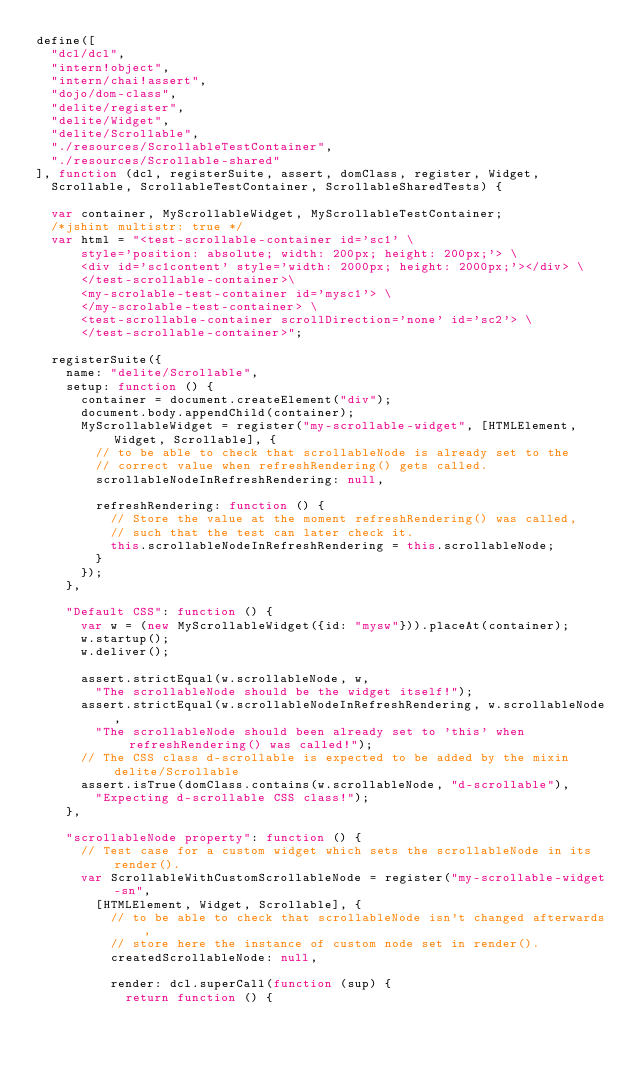Convert code to text. <code><loc_0><loc_0><loc_500><loc_500><_JavaScript_>define([
	"dcl/dcl",
	"intern!object",
	"intern/chai!assert",
	"dojo/dom-class",
	"delite/register",
	"delite/Widget",
	"delite/Scrollable",
	"./resources/ScrollableTestContainer",
	"./resources/Scrollable-shared"
], function (dcl, registerSuite, assert, domClass, register, Widget,
	Scrollable, ScrollableTestContainer, ScrollableSharedTests) {

	var container, MyScrollableWidget, MyScrollableTestContainer;
	/*jshint multistr: true */
	var html = "<test-scrollable-container id='sc1' \
			style='position: absolute; width: 200px; height: 200px;'> \
			<div id='sc1content' style='width: 2000px; height: 2000px;'></div> \
			</test-scrollable-container>\
			<my-scrolable-test-container id='mysc1'> \
			</my-scrolable-test-container> \
			<test-scrollable-container scrollDirection='none' id='sc2'> \
			</test-scrollable-container>";

	registerSuite({
		name: "delite/Scrollable",
		setup: function () {
			container = document.createElement("div");
			document.body.appendChild(container);
			MyScrollableWidget = register("my-scrollable-widget", [HTMLElement, Widget, Scrollable], {
				// to be able to check that scrollableNode is already set to the 
				// correct value when refreshRendering() gets called.
				scrollableNodeInRefreshRendering: null,

				refreshRendering: function () {
					// Store the value at the moment refreshRendering() was called,
					// such that the test can later check it.
					this.scrollableNodeInRefreshRendering = this.scrollableNode;
				}
			});
		},

		"Default CSS": function () {
			var w = (new MyScrollableWidget({id: "mysw"})).placeAt(container);
			w.startup();
			w.deliver();

			assert.strictEqual(w.scrollableNode, w,
				"The scrollableNode should be the widget itself!");
			assert.strictEqual(w.scrollableNodeInRefreshRendering, w.scrollableNode,
				"The scrollableNode should been already set to 'this' when refreshRendering() was called!");
			// The CSS class d-scrollable is expected to be added by the mixin delite/Scrollable
			assert.isTrue(domClass.contains(w.scrollableNode, "d-scrollable"),
				"Expecting d-scrollable CSS class!");
		},

		"scrollableNode property": function () {
			// Test case for a custom widget which sets the scrollableNode in its render().
			var ScrollableWithCustomScrollableNode = register("my-scrollable-widget-sn",
				[HTMLElement, Widget, Scrollable], {
					// to be able to check that scrollableNode isn't changed afterwards,
					// store here the instance of custom node set in render().
					createdScrollableNode: null,

					render: dcl.superCall(function (sup) {
						return function () {</code> 